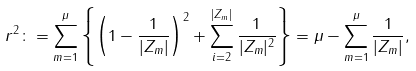Convert formula to latex. <formula><loc_0><loc_0><loc_500><loc_500>r ^ { 2 } \colon = \sum _ { m = 1 } ^ { \mu } \left \{ \left ( 1 - \frac { 1 } { | Z _ { m } | } \right ) ^ { 2 } + \sum _ { i = 2 } ^ { | Z _ { m } | } \frac { 1 } { | Z _ { m } | ^ { 2 } } \right \} = \mu - \sum _ { m = 1 } ^ { \mu } \frac { 1 } { | Z _ { m } | } ,</formula> 